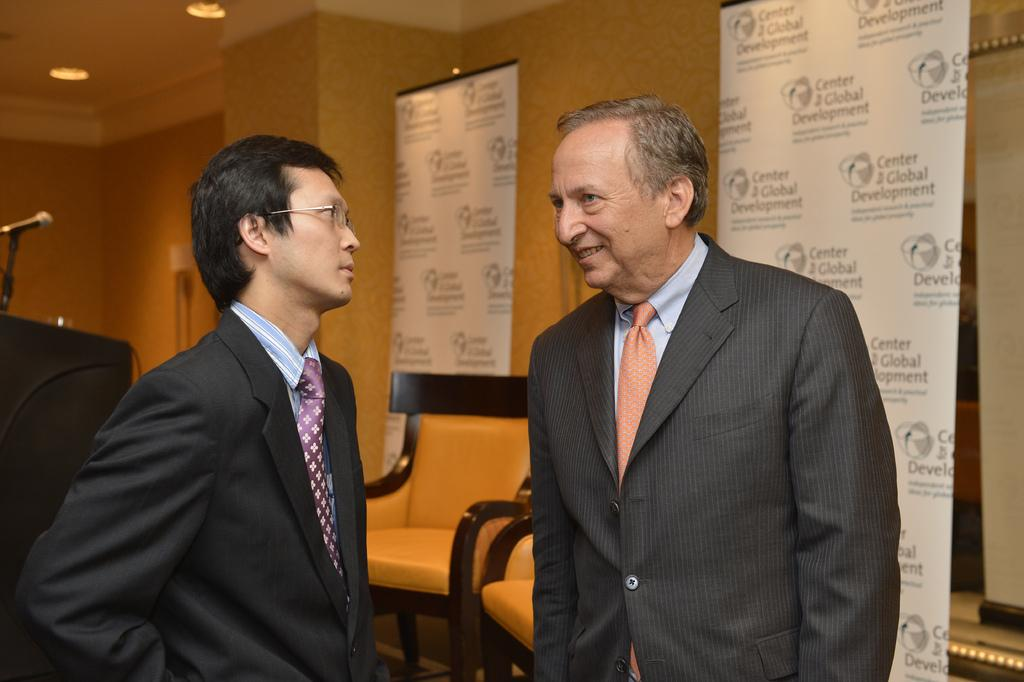How many men are standing in the image? There are two men standing in the image. What can be seen in the background behind the men? In the background, there are chairs, hoardings, a wall, and light. Can you describe the chairs in the background? The chairs in the background are not clearly visible, but they are present. What type of light is visible in the background? The light in the background is not specified, but it is mentioned as being present. What color is the hair of the spy in the image? There is no spy present in the image, and therefore no hair color can be determined. 